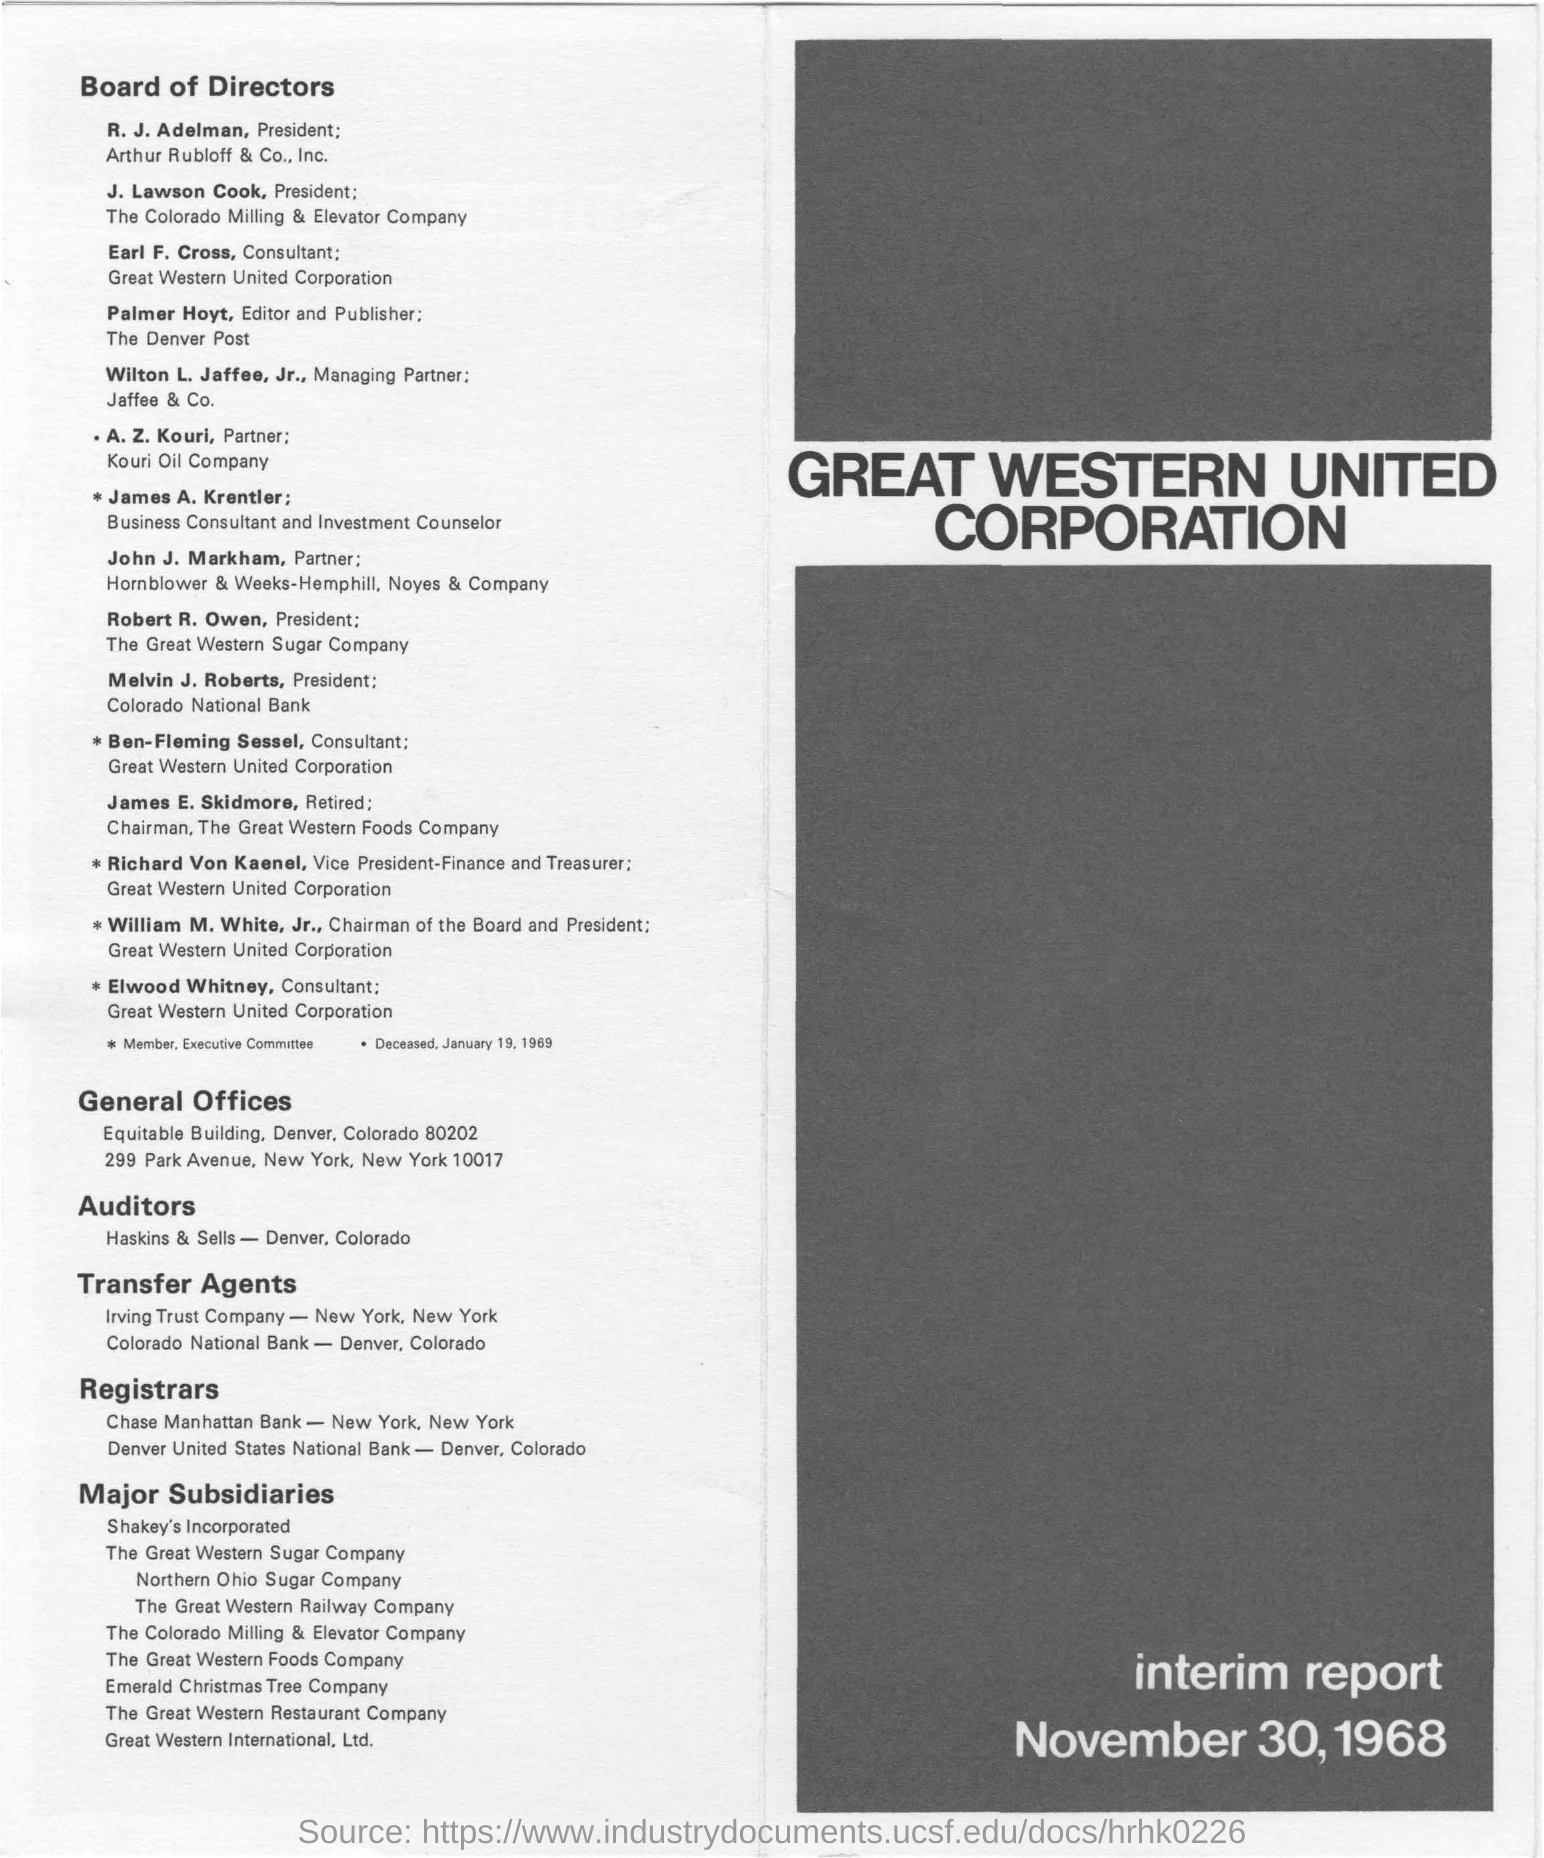Indicate a few pertinent items in this graphic. The president of Colorado National Bank is Melvin J. Roberts. The president of the Colorado Milling and Elevator Company is J. Lawson Cook. Earl F. Cross is the consultant for Western United Corporation, a prominent corporation in the Western United States. Kouri Oil Company has a partner named Z. Kouri. 